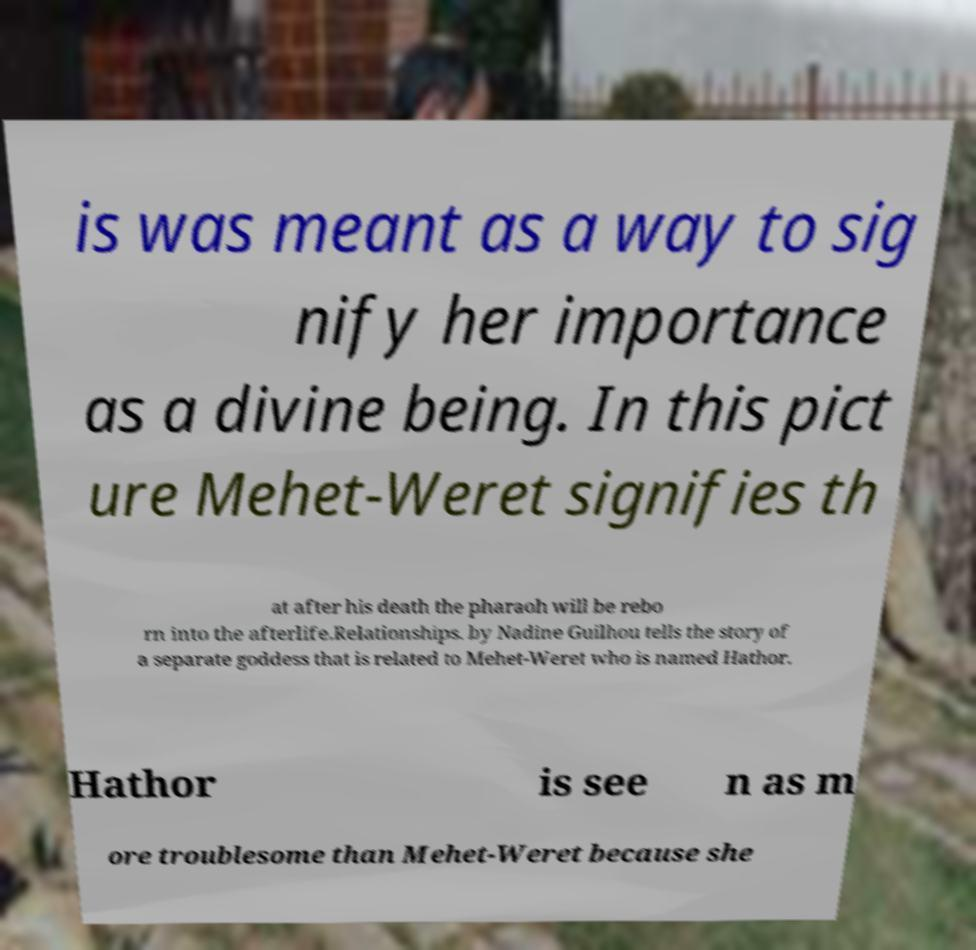Please read and relay the text visible in this image. What does it say? is was meant as a way to sig nify her importance as a divine being. In this pict ure Mehet-Weret signifies th at after his death the pharaoh will be rebo rn into the afterlife.Relationships. by Nadine Guilhou tells the story of a separate goddess that is related to Mehet-Weret who is named Hathor. Hathor is see n as m ore troublesome than Mehet-Weret because she 